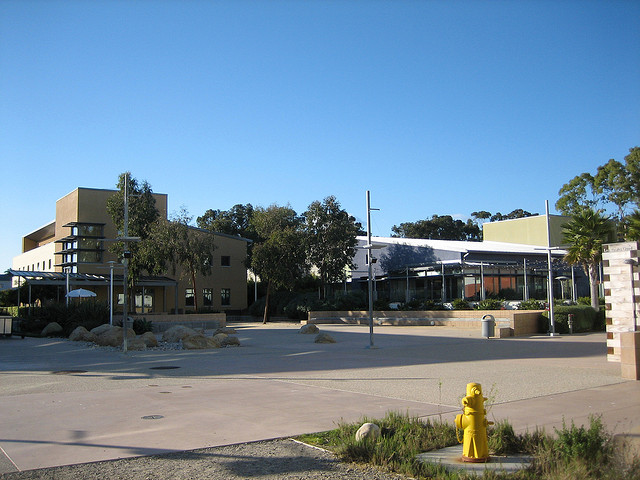Are there any people or vehicles in the image? In this particular snapshot, there are no people or vehicles visible. The space is open and tranquil, indicating a time of low activity or a less frequented area. 